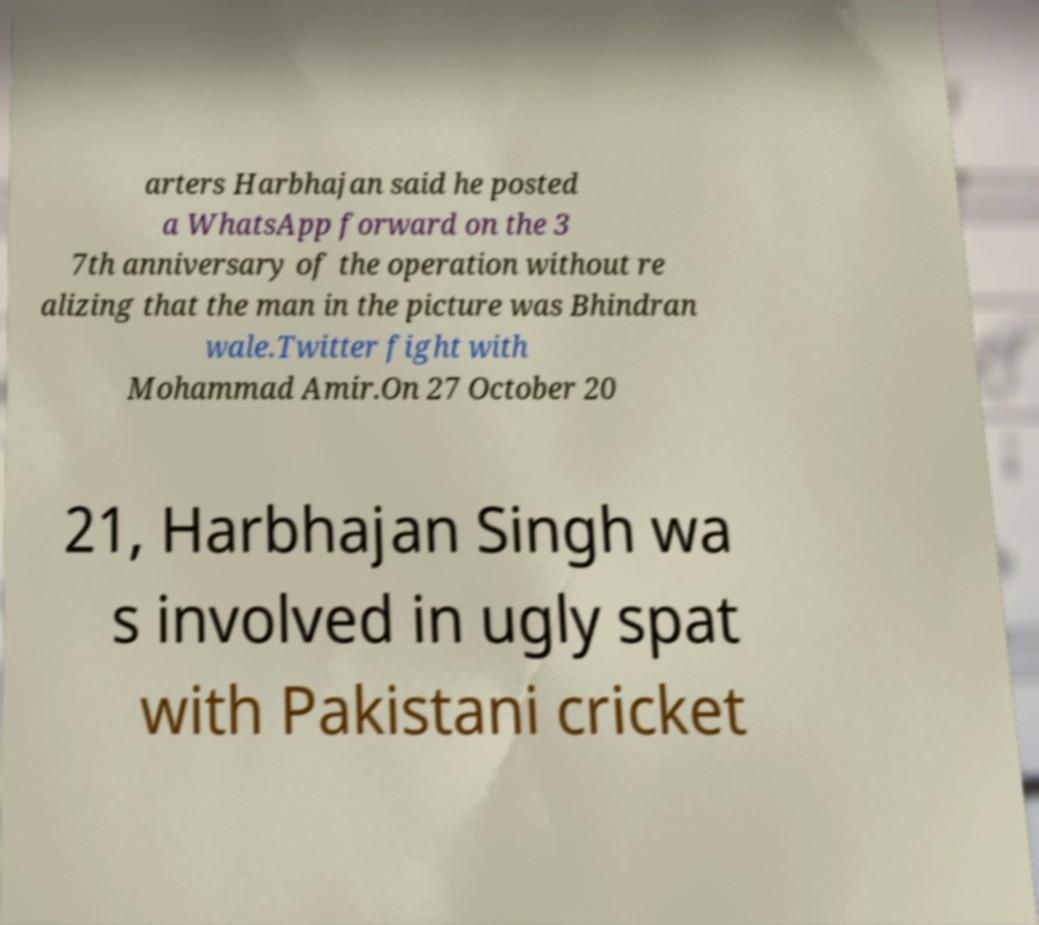Please identify and transcribe the text found in this image. arters Harbhajan said he posted a WhatsApp forward on the 3 7th anniversary of the operation without re alizing that the man in the picture was Bhindran wale.Twitter fight with Mohammad Amir.On 27 October 20 21, Harbhajan Singh wa s involved in ugly spat with Pakistani cricket 